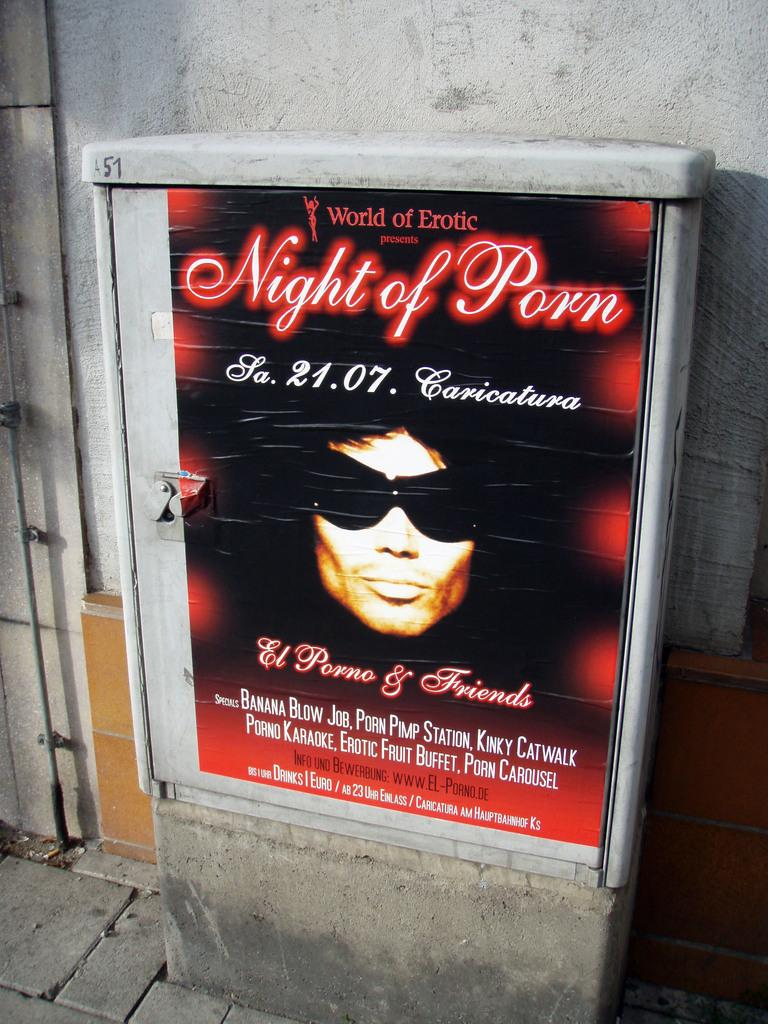<image>
Render a clear and concise summary of the photo. Boarder with World of Erotic presents Night of Porn. 